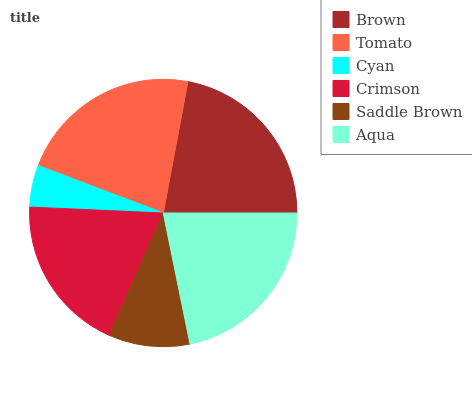Is Cyan the minimum?
Answer yes or no. Yes. Is Tomato the maximum?
Answer yes or no. Yes. Is Tomato the minimum?
Answer yes or no. No. Is Cyan the maximum?
Answer yes or no. No. Is Tomato greater than Cyan?
Answer yes or no. Yes. Is Cyan less than Tomato?
Answer yes or no. Yes. Is Cyan greater than Tomato?
Answer yes or no. No. Is Tomato less than Cyan?
Answer yes or no. No. Is Aqua the high median?
Answer yes or no. Yes. Is Crimson the low median?
Answer yes or no. Yes. Is Cyan the high median?
Answer yes or no. No. Is Aqua the low median?
Answer yes or no. No. 